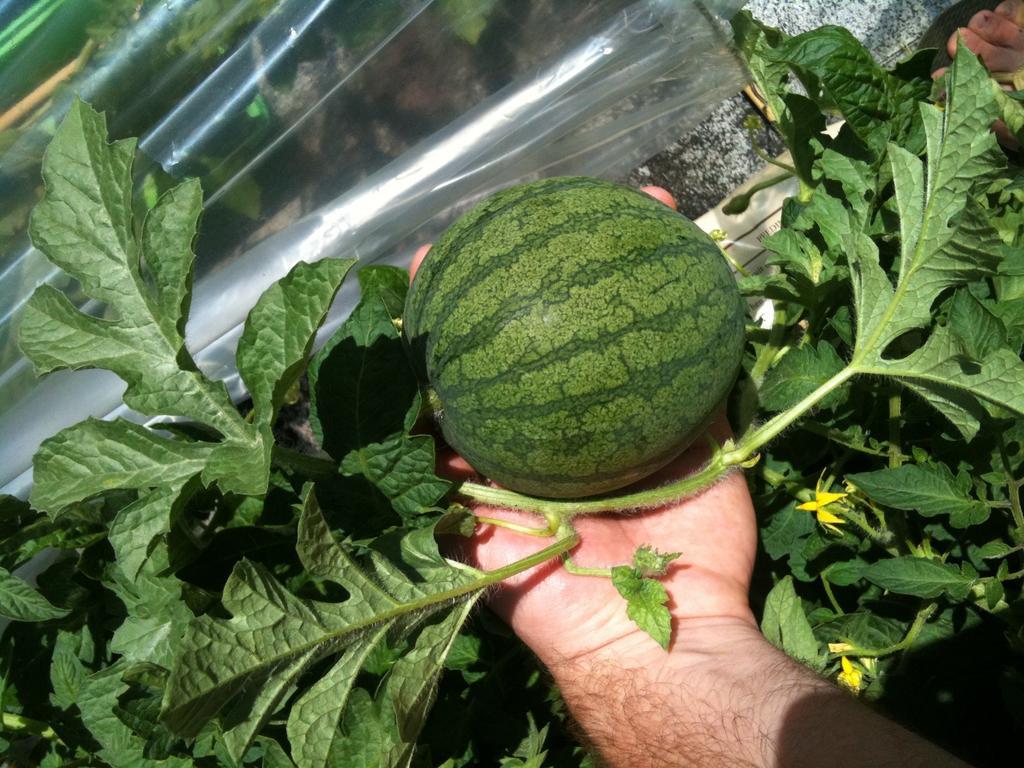Please provide a concise description of this image. In this image we can see a hand of a person holding a fruit and there are group of plants behind the hand. Behind the fruit we can see a transparent cover. 